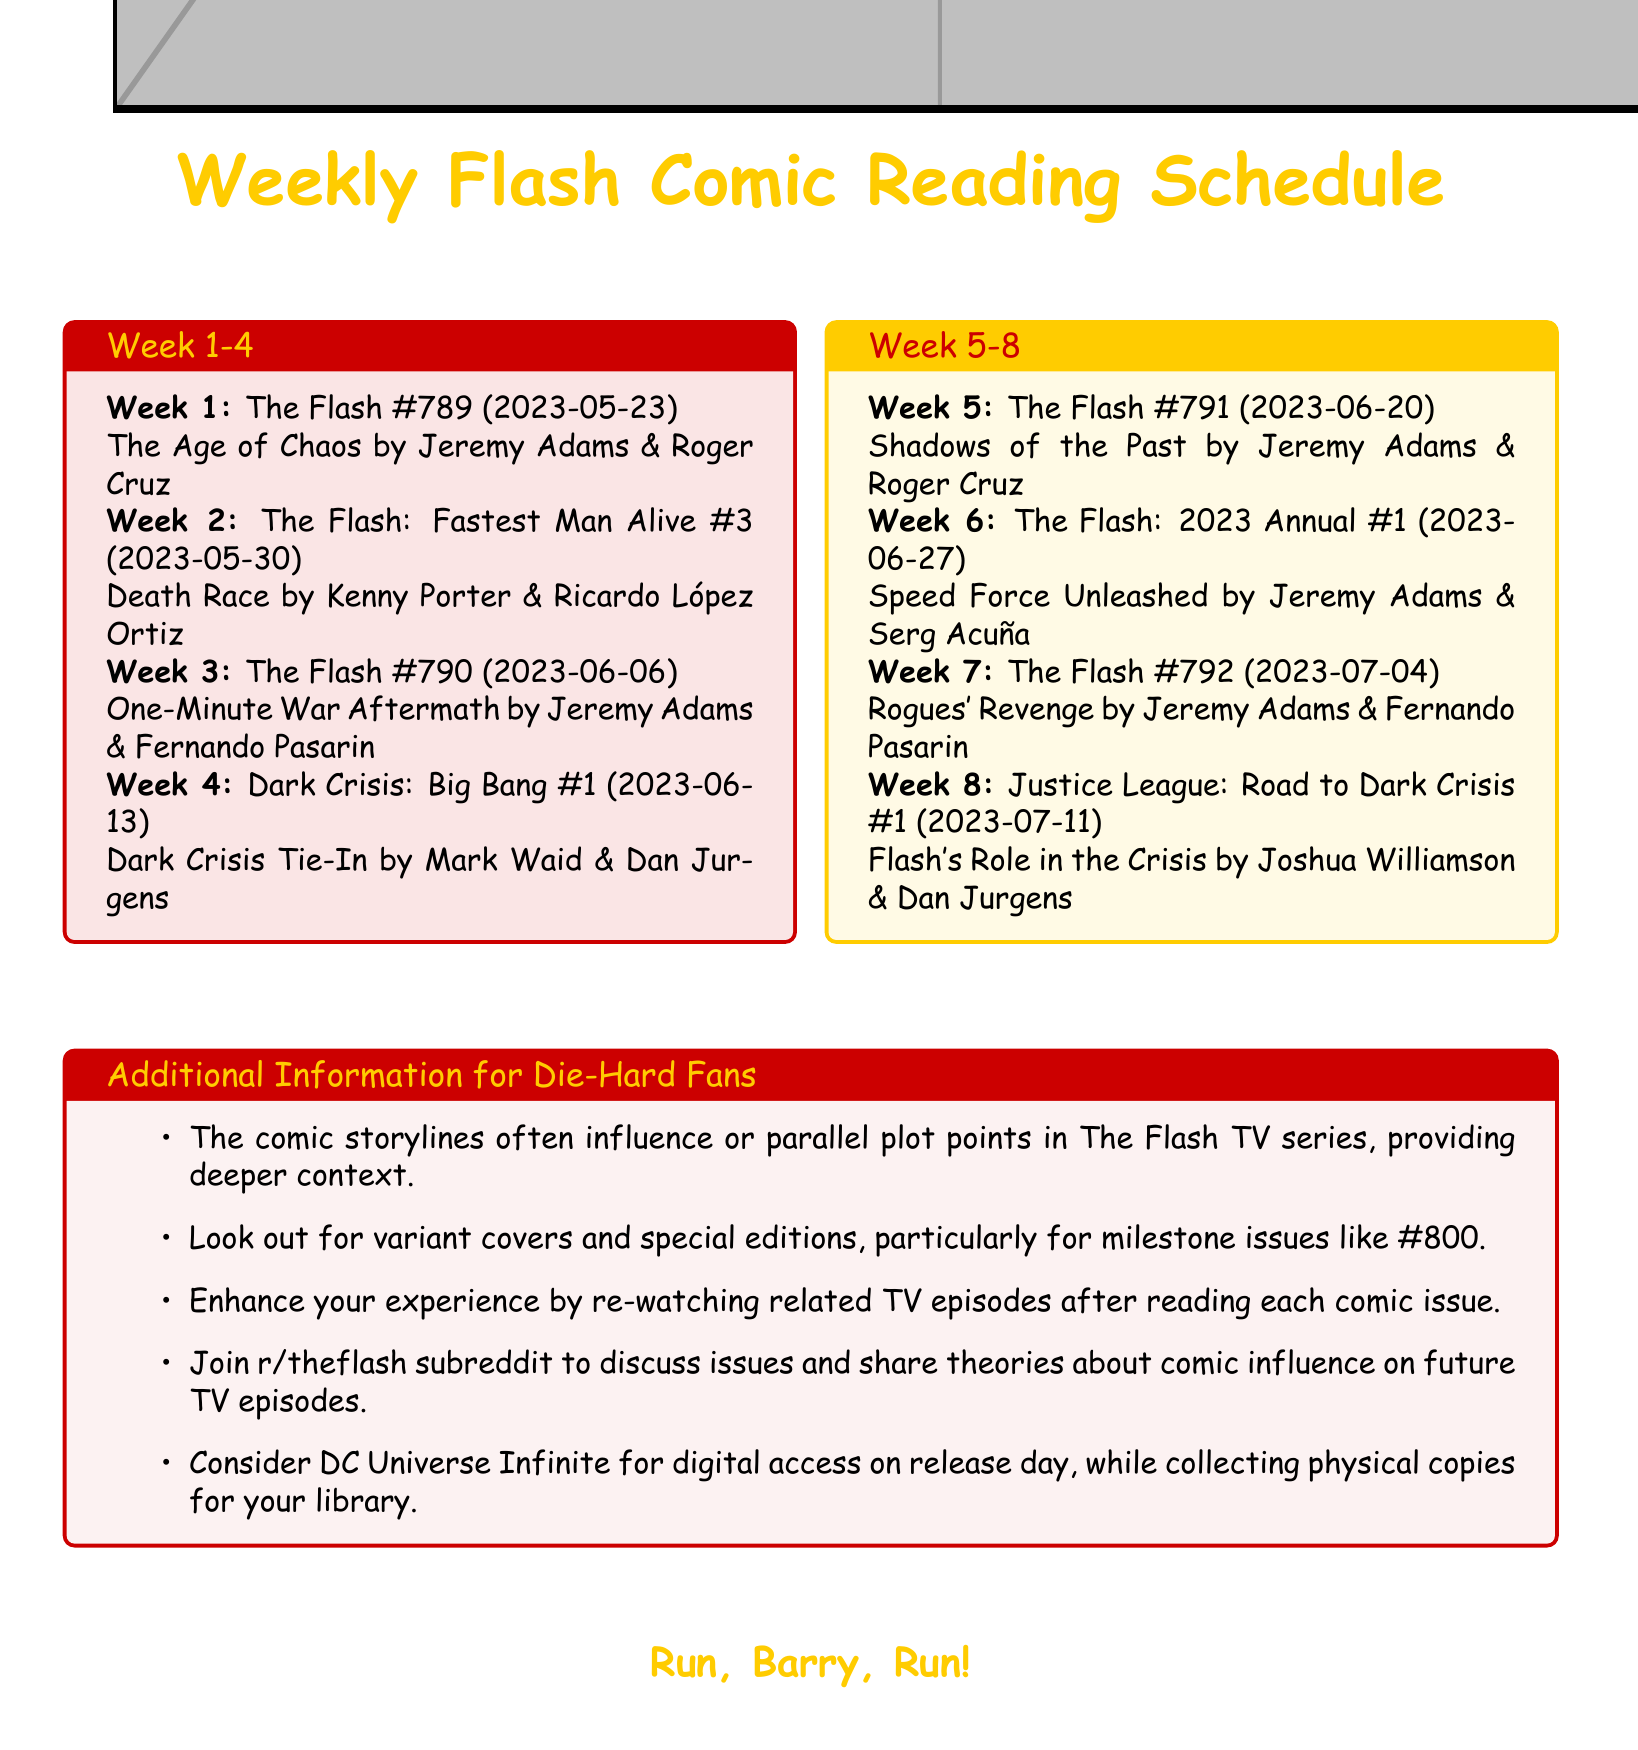What is the release date of The Flash #789? The release date is specified in the document as the date for The Flash #789.
Answer: 2023-05-23 Who is the writer for The Flash: Fastest Man Alive #3? The writer is explicitly mentioned in the document for The Flash: Fastest Man Alive #3.
Answer: Kenny Porter What storyline does The Flash #791 feature? The storyline is indicated in the document for The Flash #791 as part of the weekly reading schedule.
Answer: Shadows of the Past In which week is Justice League: Road to Dark Crisis #1 released? The document provides a scheduled week number for each comic issue.
Answer: Week 8 Who illustrated The Flash: 2023 Annual #1? The artist is noted in the document for The Flash: 2023 Annual #1.
Answer: Serg Acuña How many issues were released before The Flash #792? To find this, count the total number of issues listed prior to The Flash #792 in the document.
Answer: 7 What is a recommended way to enhance reading experience? The document suggests specific actions to enhance the experience for readers after reading each comic issue.
Answer: Re-watching related TV episodes What is the focus of the additional information section? The additional information section provides insights relevant to fans about the comic series and its connection to the TV series.
Answer: Die-Hard Fans 